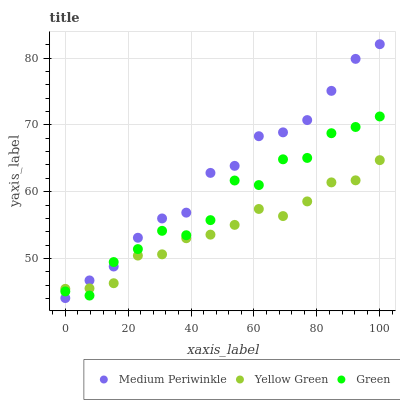Does Yellow Green have the minimum area under the curve?
Answer yes or no. Yes. Does Medium Periwinkle have the maximum area under the curve?
Answer yes or no. Yes. Does Medium Periwinkle have the minimum area under the curve?
Answer yes or no. No. Does Yellow Green have the maximum area under the curve?
Answer yes or no. No. Is Yellow Green the smoothest?
Answer yes or no. Yes. Is Green the roughest?
Answer yes or no. Yes. Is Medium Periwinkle the smoothest?
Answer yes or no. No. Is Medium Periwinkle the roughest?
Answer yes or no. No. Does Medium Periwinkle have the lowest value?
Answer yes or no. Yes. Does Yellow Green have the lowest value?
Answer yes or no. No. Does Medium Periwinkle have the highest value?
Answer yes or no. Yes. Does Yellow Green have the highest value?
Answer yes or no. No. Does Yellow Green intersect Medium Periwinkle?
Answer yes or no. Yes. Is Yellow Green less than Medium Periwinkle?
Answer yes or no. No. Is Yellow Green greater than Medium Periwinkle?
Answer yes or no. No. 